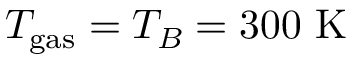Convert formula to latex. <formula><loc_0><loc_0><loc_500><loc_500>T _ { g a s } = T _ { B } = 3 0 0 K</formula> 